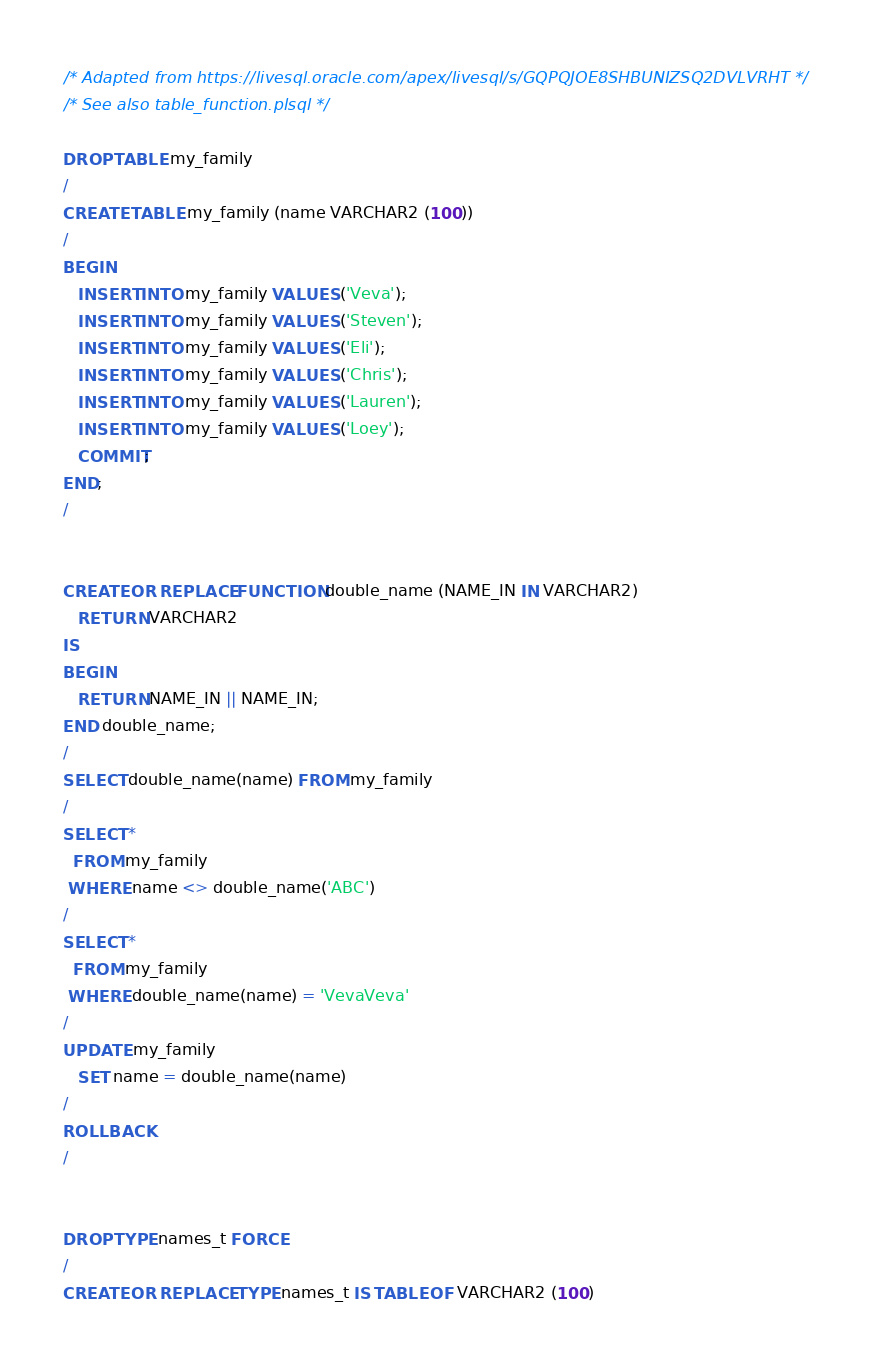Convert code to text. <code><loc_0><loc_0><loc_500><loc_500><_SQL_>/* Adapted from https://livesql.oracle.com/apex/livesql/s/GQPQJOE8SHBUNIZSQ2DVLVRHT */
/* See also table_function.plsql */

DROP TABLE my_family
/
CREATE TABLE my_family (name VARCHAR2 (100))
/
BEGIN
   INSERT INTO my_family VALUES ('Veva');
   INSERT INTO my_family VALUES ('Steven');
   INSERT INTO my_family VALUES ('Eli');
   INSERT INTO my_family VALUES ('Chris');
   INSERT INTO my_family VALUES ('Lauren');
   INSERT INTO my_family VALUES ('Loey');
   COMMIT;
END;
/


CREATE OR REPLACE FUNCTION double_name (NAME_IN IN VARCHAR2)
   RETURN VARCHAR2
IS
BEGIN
   RETURN NAME_IN || NAME_IN;
END double_name;
/
SELECT double_name(name) FROM my_family
/
SELECT *
  FROM my_family
 WHERE name <> double_name('ABC')
/
SELECT *
  FROM my_family
 WHERE double_name(name) = 'VevaVeva'
/
UPDATE my_family
   SET name = double_name(name)
/
ROLLBACK
/


DROP TYPE names_t FORCE
/
CREATE OR REPLACE TYPE names_t IS TABLE OF VARCHAR2 (100)</code> 